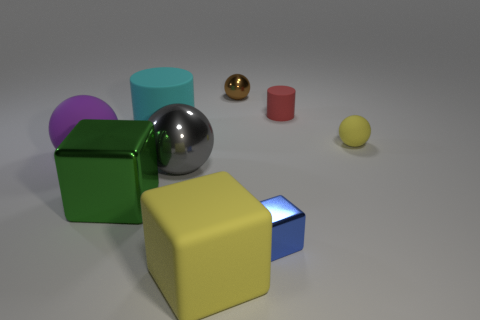What number of big yellow things have the same material as the brown ball?
Keep it short and to the point. 0. There is a ball that is the same material as the gray thing; what is its color?
Your answer should be compact. Brown. What is the size of the shiny ball to the left of the yellow rubber thing in front of the metal sphere that is in front of the big purple matte sphere?
Your answer should be compact. Large. Is the number of red rubber things less than the number of blue rubber cylinders?
Provide a short and direct response. No. What is the color of the other big rubber thing that is the same shape as the brown thing?
Give a very brief answer. Purple. Is there a ball that is on the left side of the large matte object in front of the tiny metal object that is in front of the big purple sphere?
Your answer should be compact. Yes. Is the big green object the same shape as the brown metallic object?
Offer a terse response. No. Is the number of cyan cylinders behind the big shiny cube less than the number of large shiny spheres?
Ensure brevity in your answer.  No. What is the color of the big ball that is to the left of the rubber cylinder in front of the matte cylinder to the right of the matte cube?
Ensure brevity in your answer.  Purple. How many metal objects are spheres or cubes?
Provide a succinct answer. 4. 